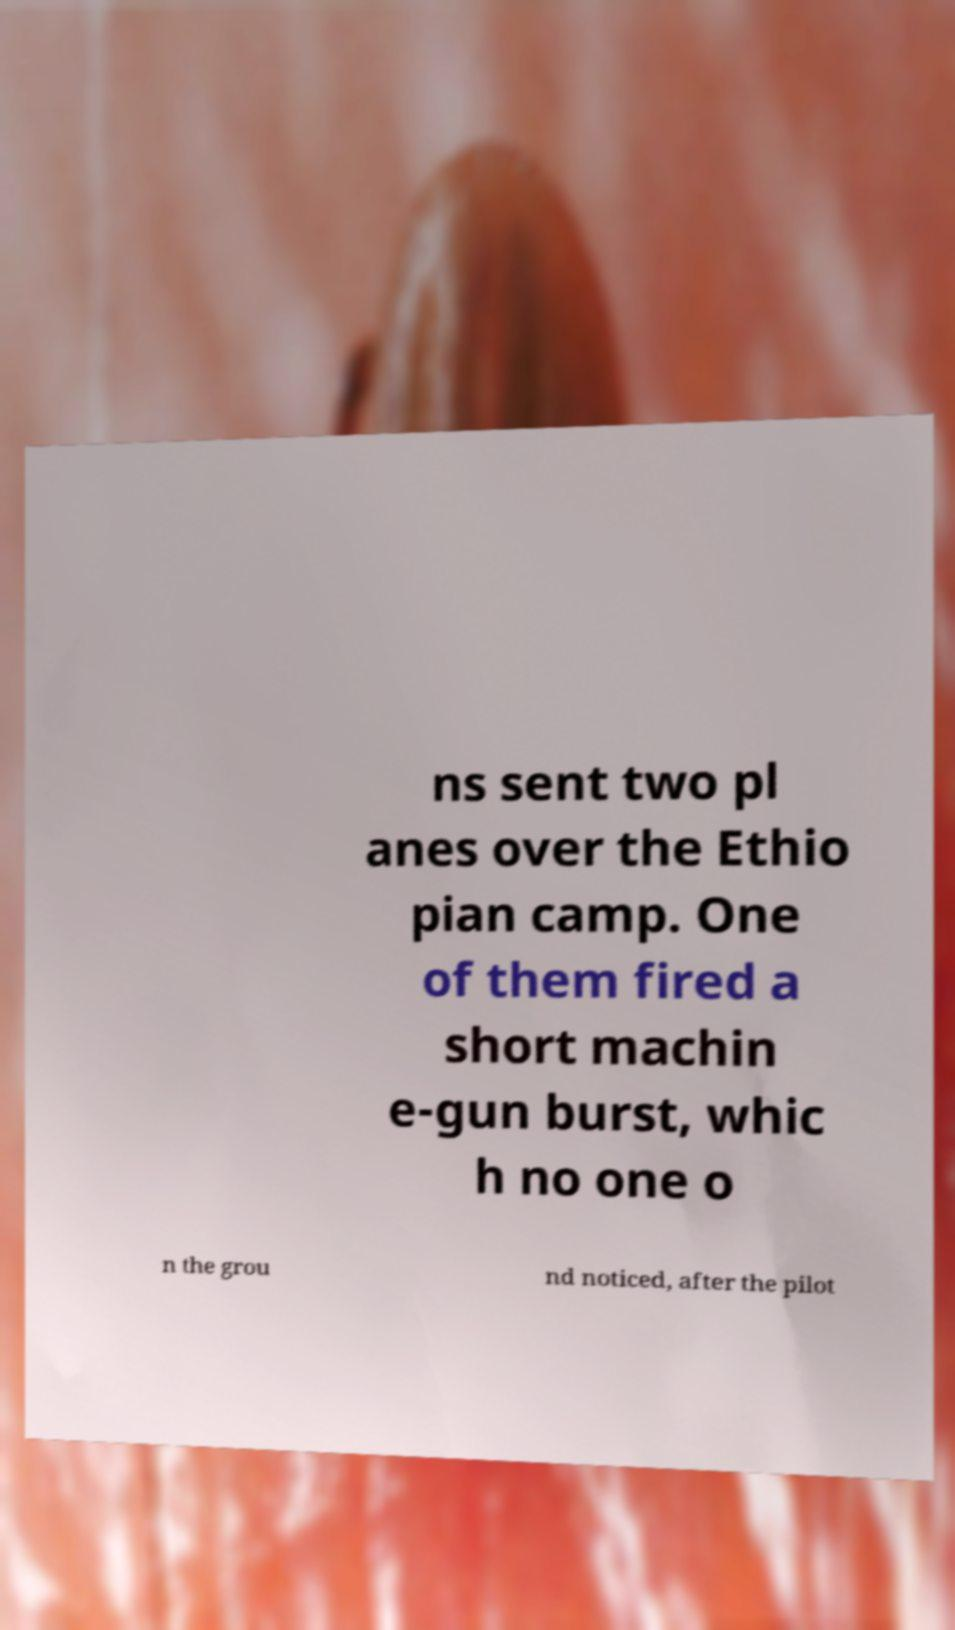Please identify and transcribe the text found in this image. ns sent two pl anes over the Ethio pian camp. One of them fired a short machin e-gun burst, whic h no one o n the grou nd noticed, after the pilot 